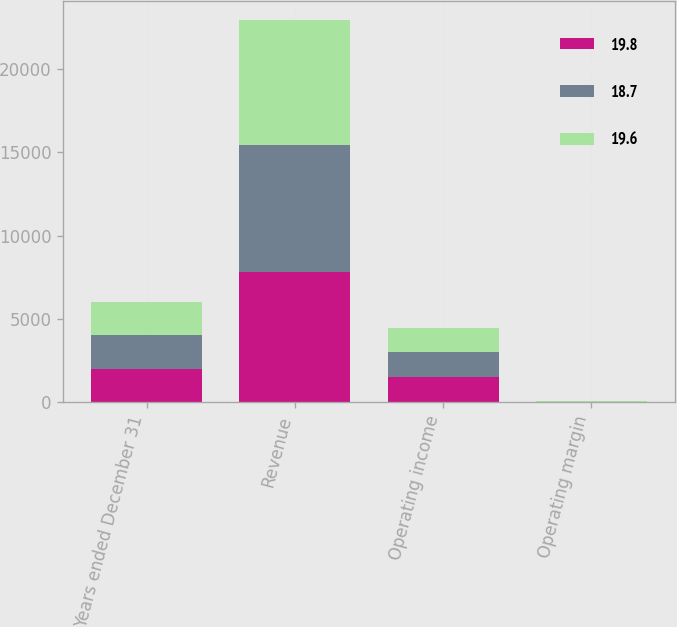Convert chart to OTSL. <chart><loc_0><loc_0><loc_500><loc_500><stacked_bar_chart><ecel><fcel>Years ended December 31<fcel>Revenue<fcel>Operating income<fcel>Operating margin<nl><fcel>19.8<fcel>2013<fcel>7789<fcel>1540<fcel>19.8<nl><fcel>18.7<fcel>2012<fcel>7632<fcel>1493<fcel>19.6<nl><fcel>19.6<fcel>2011<fcel>7537<fcel>1413<fcel>18.7<nl></chart> 